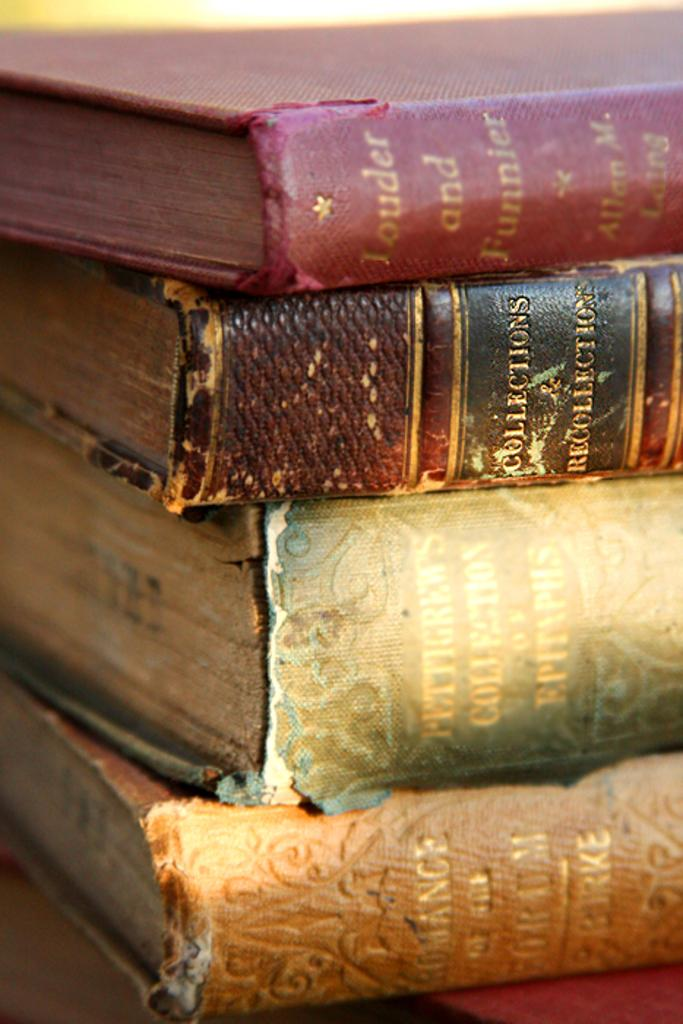<image>
Present a compact description of the photo's key features. Four very old books are stacked on each other and the top book is titled Louder and Funnier. 